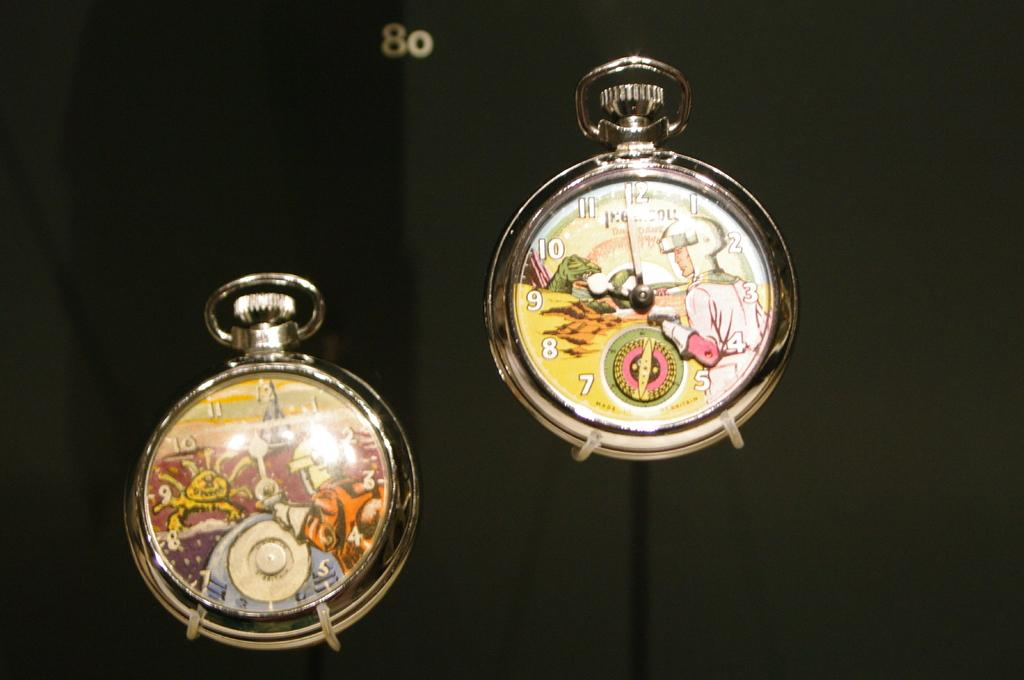<image>
Relay a brief, clear account of the picture shown. Two watches with the number 80 above them. 